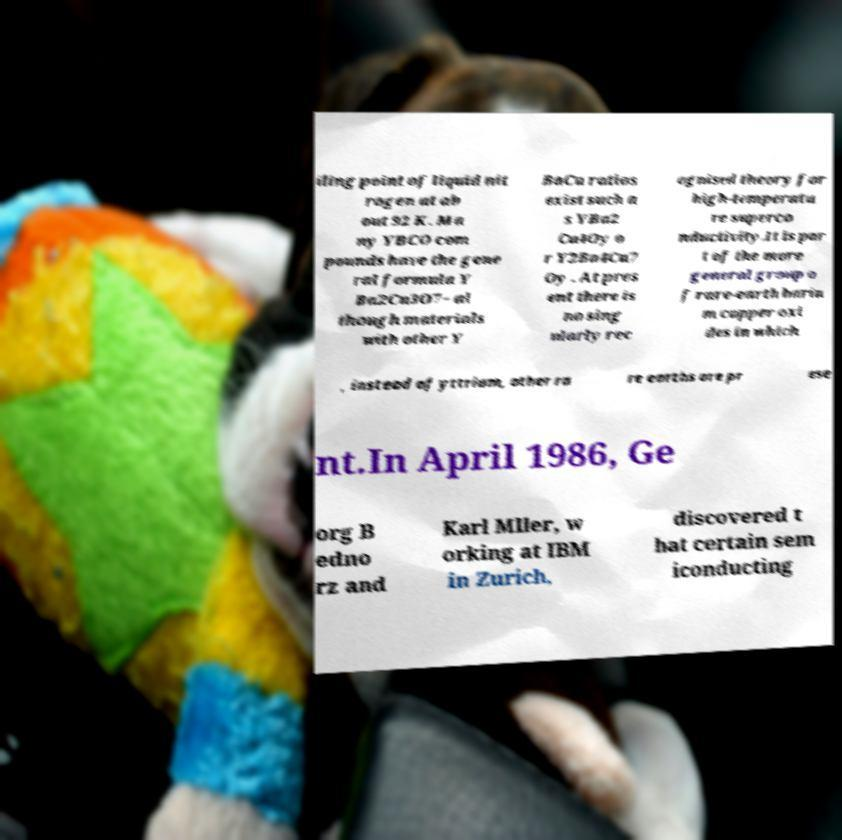There's text embedded in this image that I need extracted. Can you transcribe it verbatim? iling point of liquid nit rogen at ab out 92 K. Ma ny YBCO com pounds have the gene ral formula Y Ba2Cu3O7− al though materials with other Y BaCu ratios exist such a s YBa2 Cu4Oy o r Y2Ba4Cu7 Oy . At pres ent there is no sing ularly rec ognised theory for high-temperatu re superco nductivity.It is par t of the more general group o f rare-earth bariu m copper oxi des in which , instead of yttrium, other ra re earths are pr ese nt.In April 1986, Ge org B edno rz and Karl Mller, w orking at IBM in Zurich, discovered t hat certain sem iconducting 